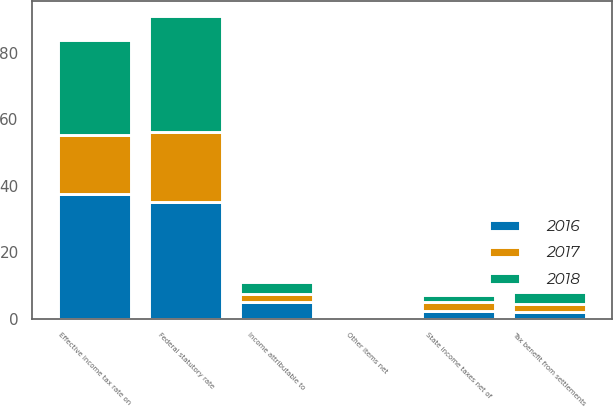Convert chart to OTSL. <chart><loc_0><loc_0><loc_500><loc_500><stacked_bar_chart><ecel><fcel>Federal statutory rate<fcel>State income taxes net of<fcel>Tax benefit from settlements<fcel>Other items net<fcel>Effective income tax rate on<fcel>Income attributable to<nl><fcel>2017<fcel>21<fcel>2.9<fcel>2.4<fcel>0.2<fcel>17.7<fcel>2.3<nl><fcel>2016<fcel>35<fcel>2.2<fcel>2<fcel>0.5<fcel>37.4<fcel>5.1<nl><fcel>2018<fcel>35<fcel>2.1<fcel>3.6<fcel>0.2<fcel>28.7<fcel>3.6<nl></chart> 